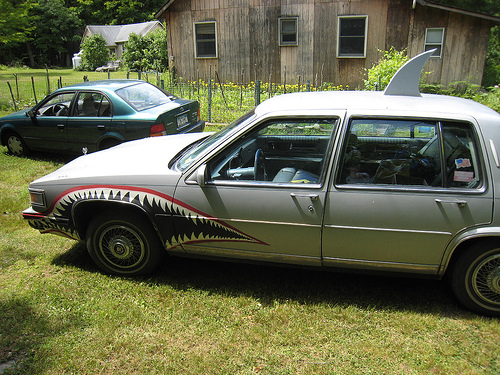<image>
Is there a car on the ground? Yes. Looking at the image, I can see the car is positioned on top of the ground, with the ground providing support. Where is the handle in relation to the door? Is it on the door? No. The handle is not positioned on the door. They may be near each other, but the handle is not supported by or resting on top of the door. Is there a green car in the house? No. The green car is not contained within the house. These objects have a different spatial relationship. 